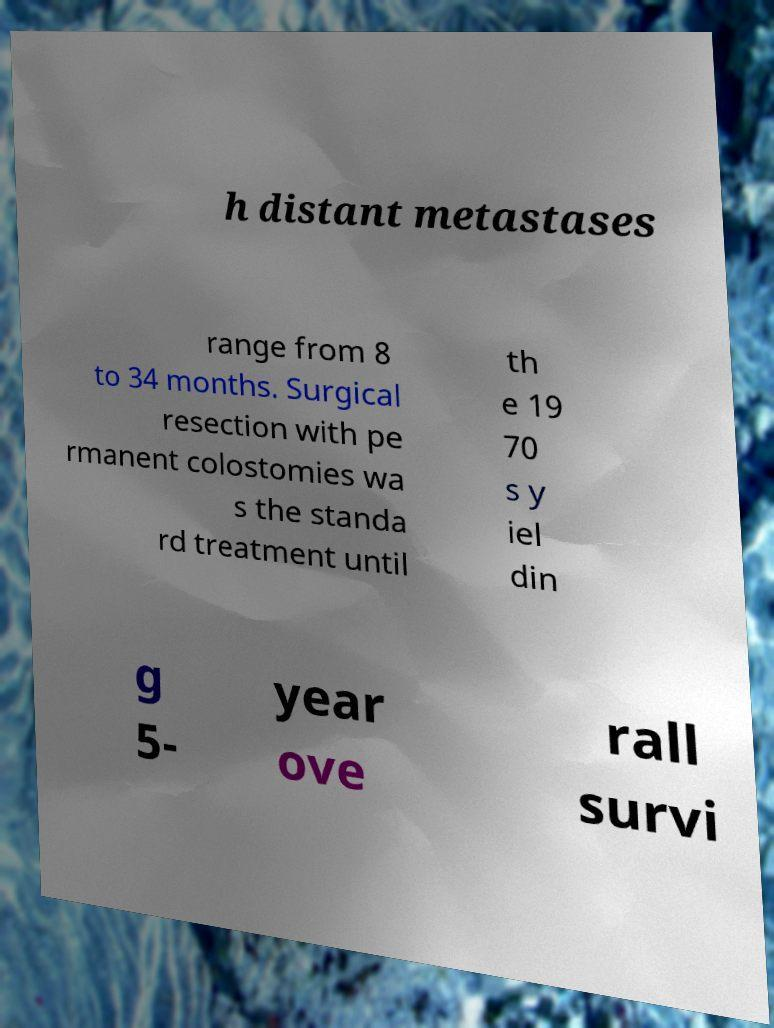Please identify and transcribe the text found in this image. h distant metastases range from 8 to 34 months. Surgical resection with pe rmanent colostomies wa s the standa rd treatment until th e 19 70 s y iel din g 5- year ove rall survi 